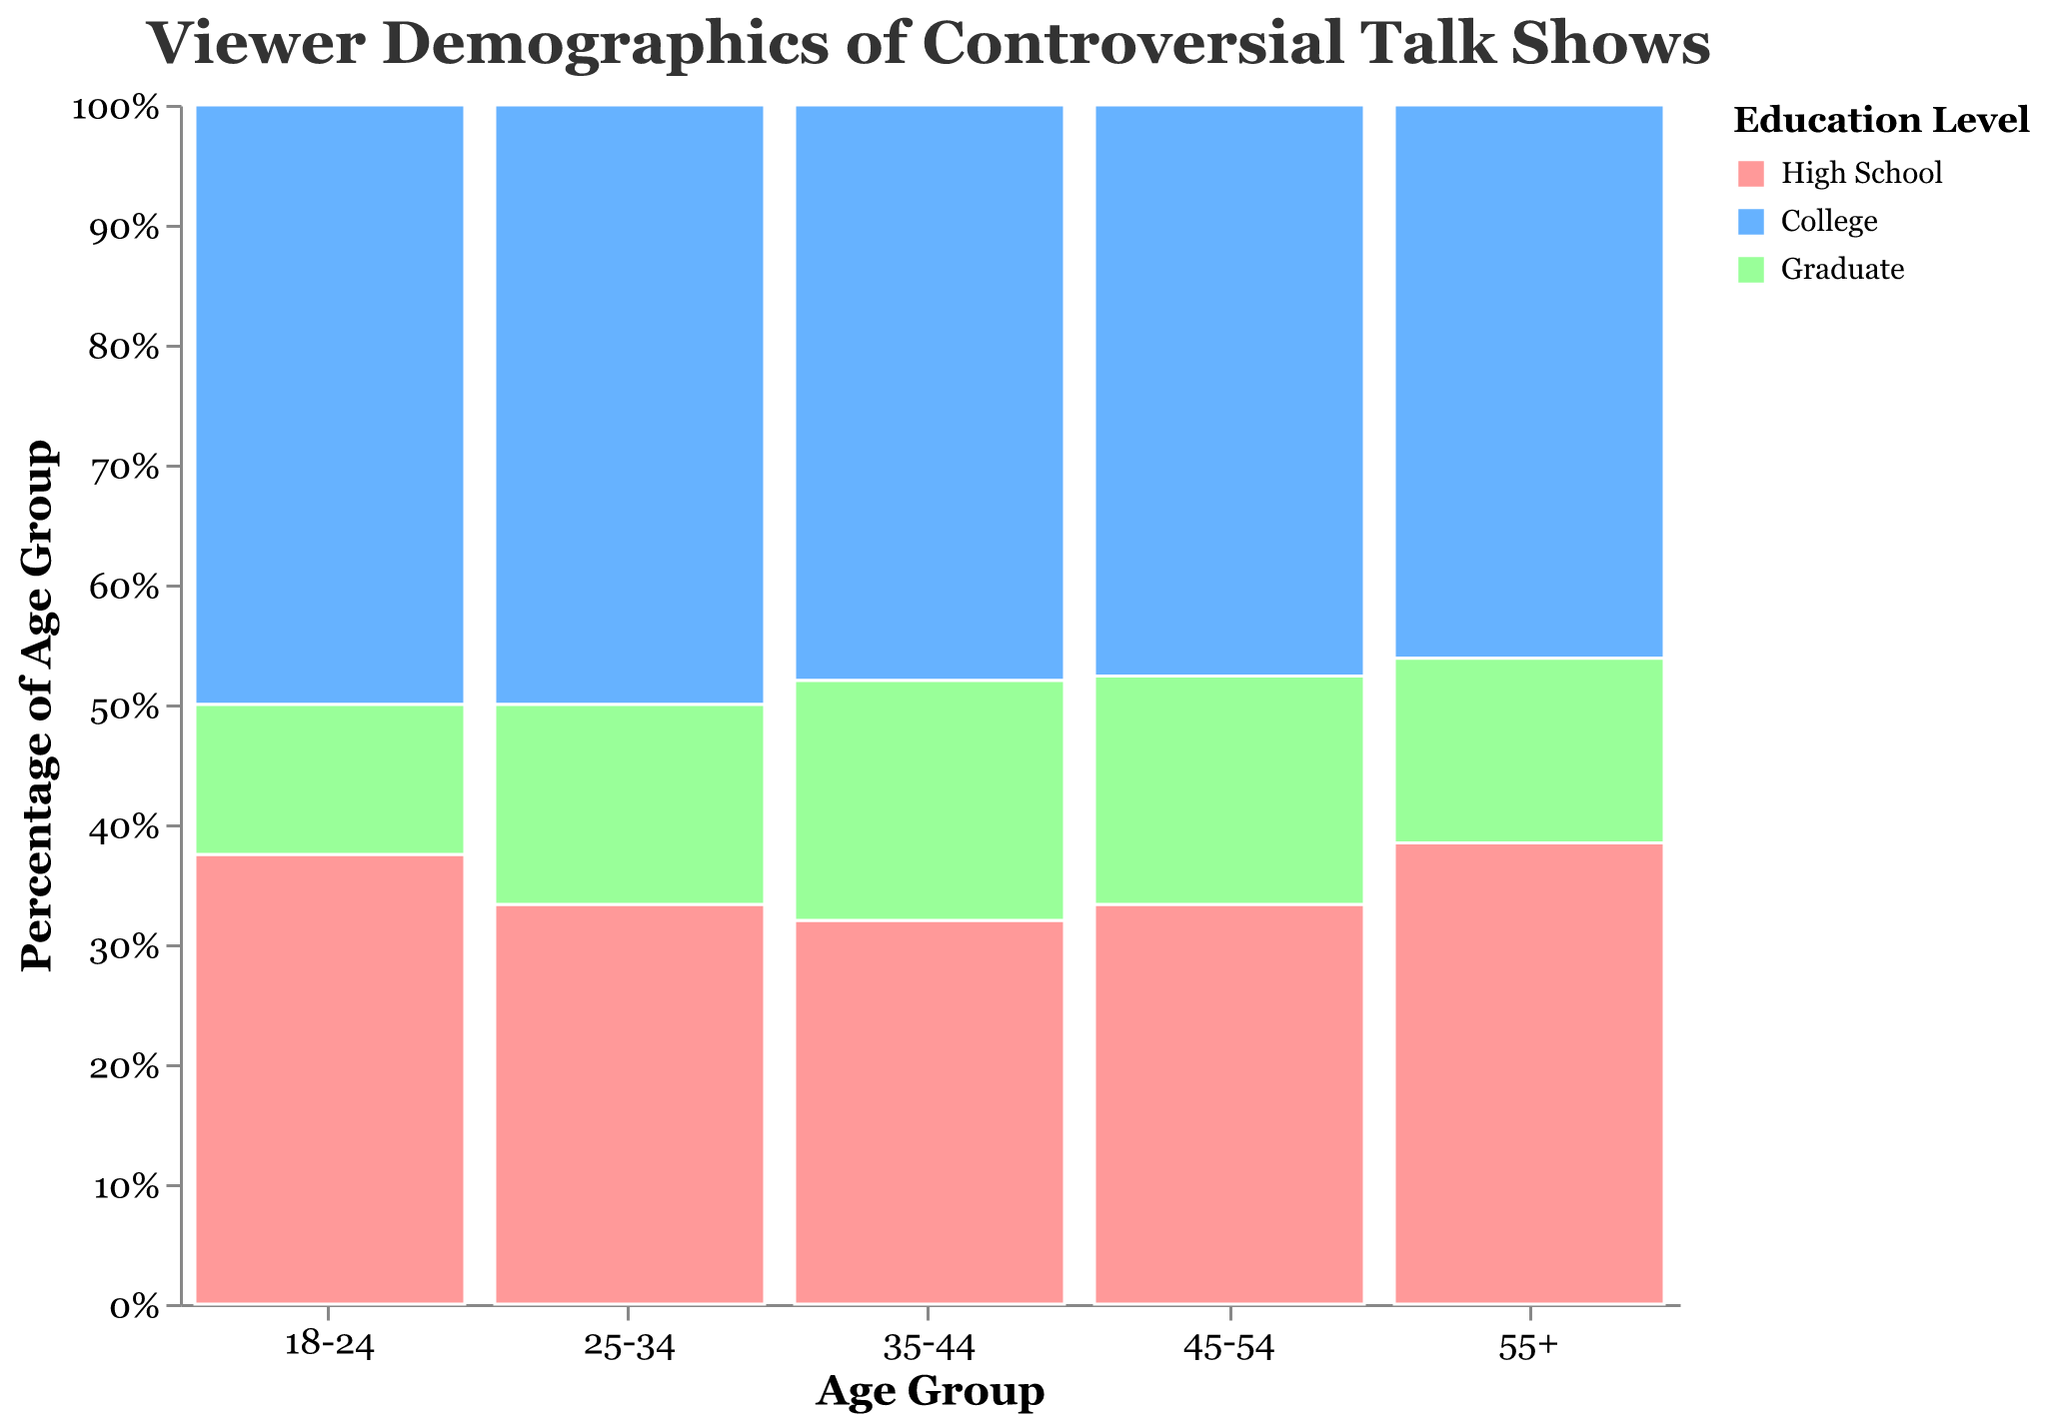What is the title of the mosaic plot? The title of the mosaic plot is given at the top of the chart and represents the subject of the plot. It directly states the focus of the visualization.
Answer: Viewer Demographics of Controversial Talk Shows Which age group has the highest total viewer count for college-educated viewers? To identify the age group with the highest total viewer count for college-educated viewers, look at the segments in the mosaic plot colored for "College" and compare their sizes. The larger the segment, the higher the viewer count.
Answer: 35-44 What percentage of the 25-34 age group has a high school education? The percentage of the 25-34 age group with a high school education is found by looking at the "25-34" column and identifying the height of the "High School" segment relative to the total height of the column. The axis on the y-axis helps in determining the approximate percentage.
Answer: Around 33% What is the total number of viewers in the 45-54 age group? Sum the viewer counts for all education levels in the 45-54 age group by observing the sizes of all segments within this age group's column. High School: 350,000, College: 500,000, Graduate: 200,000.
Answer: 1,050,000 How does the viewer distribution in the 18-24 age group compare to the 55+ age group in terms of education levels? To compare the viewer distribution between the 18-24 and 55+ age groups, observe the relative heights of segments within these columns. In the 18-24 group: High School: 150,000, College: 200,000, Graduate: 50,000. In the 55+ group: High School: 250,000, College: 300,000, Graduate: 100,000. Both groups have the highest counts in the College category, but the 55+ group generally has higher counts across all education levels.
Answer: The 55+ age group has higher viewer counts across all education levels compared to the 18-24 age group Which education level has the least viewers in the 25-34 age group? By comparing the heights of the segments within the 25-34 age group column, identify the smallest segment. High School: 300,000, College: 450,000, Graduate: 150,000.
Answer: Graduate What patterns can be seen in the viewer demographics by education level across all age groups? Look at the viewer count distributions by education level across age groups and identify trends. "College" segments generally have the highest counts within each age group and "Graduate" segments have the lowest counts. This pattern suggests college-educated viewers are the largest demographic, followed by high school and graduate viewers.
Answer: College-educated viewers dominate across all age groups Which age group has the highest percentage of viewers with a graduate education level? To find the age group with the highest percentage of viewers with a graduate education level, compare the graduate sections' relative heights across all age group columns.
Answer: 35-44 What is the total number of college-educated viewers across all age groups? Sum the viewer counts in the "College" segments across all age groups: 200,000 (18-24) + 450,000 (25-34) + 600,000 (35-44) + 500,000 (45-54) + 300,000 (55+).
Answer: 2,050,000 